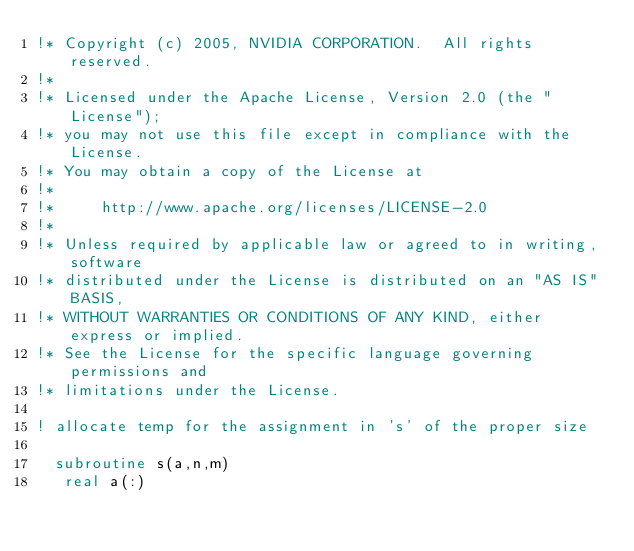<code> <loc_0><loc_0><loc_500><loc_500><_FORTRAN_>!* Copyright (c) 2005, NVIDIA CORPORATION.  All rights reserved.
!*
!* Licensed under the Apache License, Version 2.0 (the "License");
!* you may not use this file except in compliance with the License.
!* You may obtain a copy of the License at
!*
!*     http://www.apache.org/licenses/LICENSE-2.0
!*
!* Unless required by applicable law or agreed to in writing, software
!* distributed under the License is distributed on an "AS IS" BASIS,
!* WITHOUT WARRANTIES OR CONDITIONS OF ANY KIND, either express or implied.
!* See the License for the specific language governing permissions and
!* limitations under the License.

! allocate temp for the assignment in 's' of the proper size

	subroutine s(a,n,m)
	 real a(:)</code> 